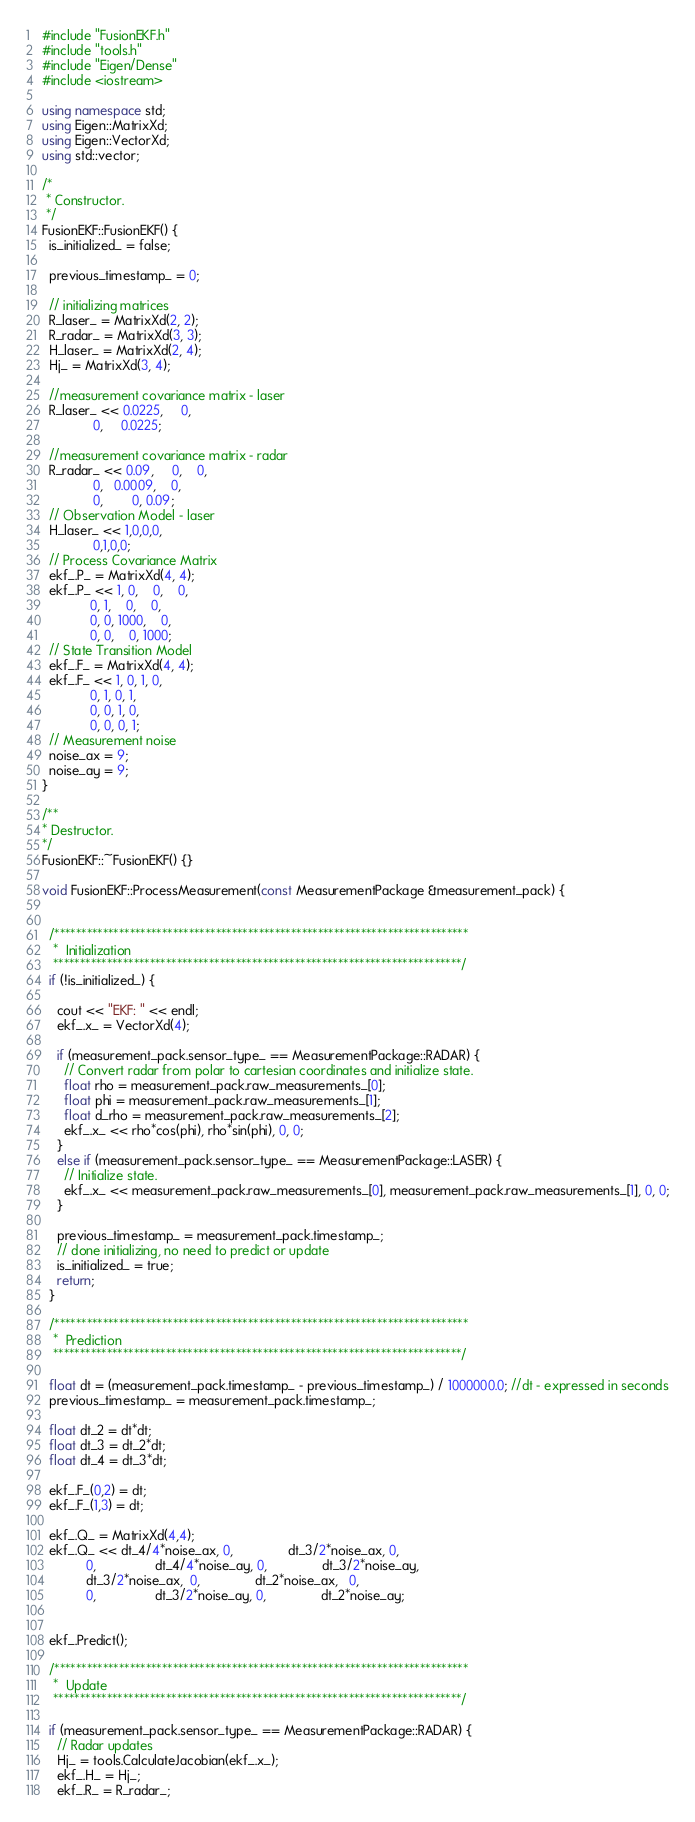Convert code to text. <code><loc_0><loc_0><loc_500><loc_500><_C++_>#include "FusionEKF.h"
#include "tools.h"
#include "Eigen/Dense"
#include <iostream>

using namespace std;
using Eigen::MatrixXd;
using Eigen::VectorXd;
using std::vector;

/*
 * Constructor.
 */
FusionEKF::FusionEKF() {
  is_initialized_ = false;

  previous_timestamp_ = 0;

  // initializing matrices
  R_laser_ = MatrixXd(2, 2);
  R_radar_ = MatrixXd(3, 3);
  H_laser_ = MatrixXd(2, 4);
  Hj_ = MatrixXd(3, 4);

  //measurement covariance matrix - laser
  R_laser_ << 0.0225,     0,
              0,     0.0225;

  //measurement covariance matrix - radar
  R_radar_ << 0.09,     0,    0,
              0,   0.0009,    0,
              0,        0, 0.09;
  // Observation Model - laser
  H_laser_ << 1,0,0,0,
              0,1,0,0;
  // Process Covariance Matrix
  ekf_.P_ = MatrixXd(4, 4);
  ekf_.P_ << 1, 0,    0,    0,
             0, 1,    0,    0,
             0, 0, 1000,    0,
             0, 0,    0, 1000;
  // State Transition Model
  ekf_.F_ = MatrixXd(4, 4);
  ekf_.F_ << 1, 0, 1, 0,
             0, 1, 0, 1,
             0, 0, 1, 0,
             0, 0, 0, 1;
  // Measurement noise 
  noise_ax = 9;
  noise_ay = 9;
}

/**
* Destructor.
*/
FusionEKF::~FusionEKF() {}

void FusionEKF::ProcessMeasurement(const MeasurementPackage &measurement_pack) {


  /*****************************************************************************
   *  Initialization
   ****************************************************************************/
  if (!is_initialized_) {

    cout << "EKF: " << endl;
    ekf_.x_ = VectorXd(4);

    if (measurement_pack.sensor_type_ == MeasurementPackage::RADAR) {
      // Convert radar from polar to cartesian coordinates and initialize state.
      float rho = measurement_pack.raw_measurements_[0];
      float phi = measurement_pack.raw_measurements_[1];
      float d_rho = measurement_pack.raw_measurements_[2];
      ekf_.x_ << rho*cos(phi), rho*sin(phi), 0, 0;
    }
    else if (measurement_pack.sensor_type_ == MeasurementPackage::LASER) {
      // Initialize state.
      ekf_.x_ << measurement_pack.raw_measurements_[0], measurement_pack.raw_measurements_[1], 0, 0;
    }

    previous_timestamp_ = measurement_pack.timestamp_;
    // done initializing, no need to predict or update
    is_initialized_ = true;
    return;
  }

  /*****************************************************************************
   *  Prediction
   ****************************************************************************/

  float dt = (measurement_pack.timestamp_ - previous_timestamp_) / 1000000.0; //dt - expressed in seconds
  previous_timestamp_ = measurement_pack.timestamp_;

  float dt_2 = dt*dt;
  float dt_3 = dt_2*dt;
  float dt_4 = dt_3*dt;

  ekf_.F_(0,2) = dt;
  ekf_.F_(1,3) = dt;

  ekf_.Q_ = MatrixXd(4,4);
  ekf_.Q_ << dt_4/4*noise_ax, 0,               dt_3/2*noise_ax, 0,
            0,                dt_4/4*noise_ay, 0,               dt_3/2*noise_ay,
            dt_3/2*noise_ax,  0,               dt_2*noise_ax,   0,
            0,                dt_3/2*noise_ay, 0,               dt_2*noise_ay;


  ekf_.Predict();

  /*****************************************************************************
   *  Update
   ****************************************************************************/

  if (measurement_pack.sensor_type_ == MeasurementPackage::RADAR) {
    // Radar updates
    Hj_ = tools.CalculateJacobian(ekf_.x_);
    ekf_.H_ = Hj_;
    ekf_.R_ = R_radar_;</code> 